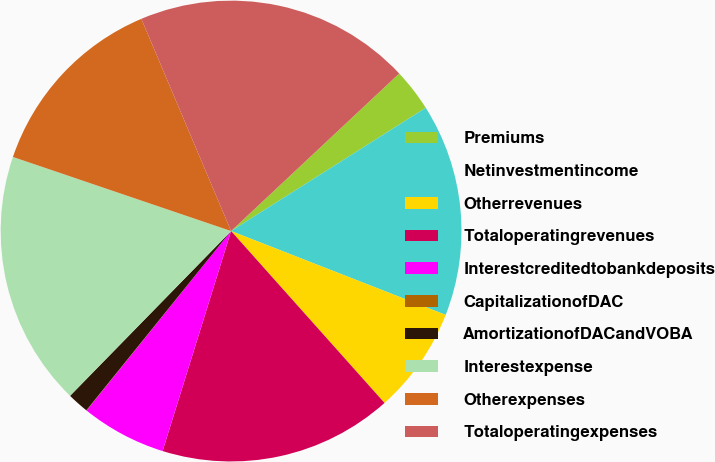Convert chart to OTSL. <chart><loc_0><loc_0><loc_500><loc_500><pie_chart><fcel>Premiums<fcel>Netinvestmentincome<fcel>Otherrevenues<fcel>Totaloperatingrevenues<fcel>Interestcreditedtobankdeposits<fcel>CapitalizationofDAC<fcel>AmortizationofDACandVOBA<fcel>Interestexpense<fcel>Otherexpenses<fcel>Totaloperatingexpenses<nl><fcel>3.0%<fcel>14.91%<fcel>7.47%<fcel>16.4%<fcel>5.98%<fcel>0.02%<fcel>1.51%<fcel>17.89%<fcel>13.42%<fcel>19.38%<nl></chart> 